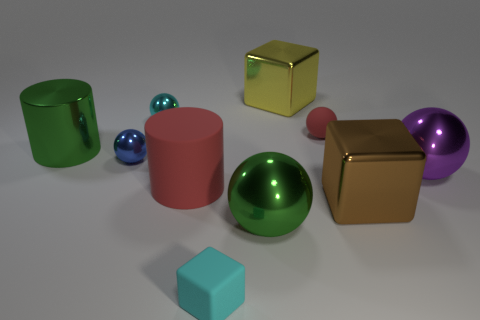Subtract all small cyan shiny balls. How many balls are left? 4 Subtract all gray balls. Subtract all gray blocks. How many balls are left? 5 Subtract all cylinders. How many objects are left? 8 Subtract 1 green cylinders. How many objects are left? 9 Subtract all big metallic things. Subtract all large shiny cylinders. How many objects are left? 4 Add 8 yellow blocks. How many yellow blocks are left? 9 Add 3 red cylinders. How many red cylinders exist? 4 